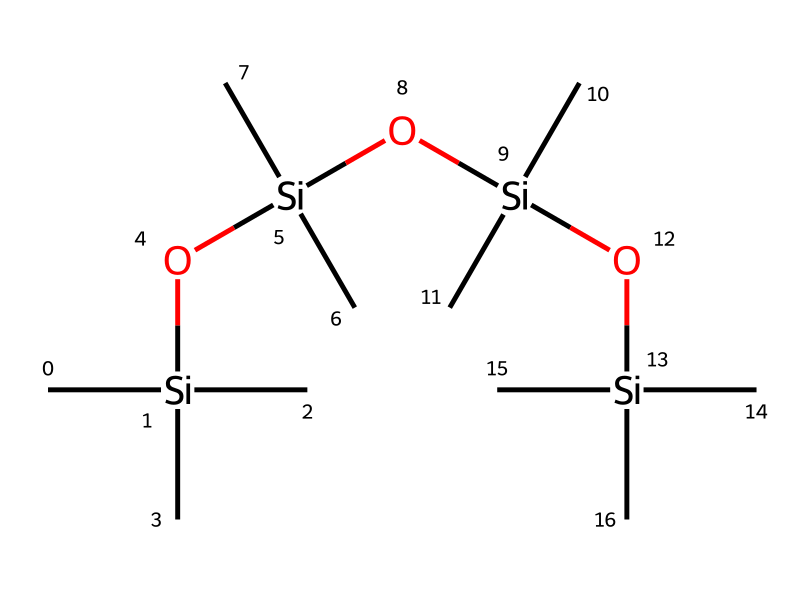How many silicon atoms are present in this structure? By examining the SMILES representation, we can count the number of occurrences of the silicon atom symbol "Si". There are four instances of "Si" in the SMILES string, indicating there are four silicon atoms.
Answer: four What is the total number of oxygen atoms in the chemical? In the provided SMILES, the oxygen atom is represented by the letter "O". By counting the occurrences of "O" in the structure, we find there are three oxygen atoms present.
Answer: three What type of chemical is indicated by this structure? The presence of silicon and carbon atoms in the structure, along with the specific arrangement involving silicon-oxygen bonds (siloxane), indicates that this is an organosilicon compound.
Answer: organosilicon What is the functional group characteristic of this compound? The repeating units of "Si-O" indicate the presence of siloxane linkages, which are typical functional groups in organosilicon compounds, highlighting their unique properties.
Answer: siloxane What is the likely application of this compound in special effects makeup? Given the flexibility and stability of organosilicon compounds, this structure can be used to create silicone-based prosthetics, which conform well to skin and can replicate textures realistically.
Answer: prosthetics How many carbon atoms are represented in the structure? Each "C" in the SMILES denotes a carbon atom. Counting the carbons reveals a total of twelve carbon atoms within the structure.
Answer: twelve 